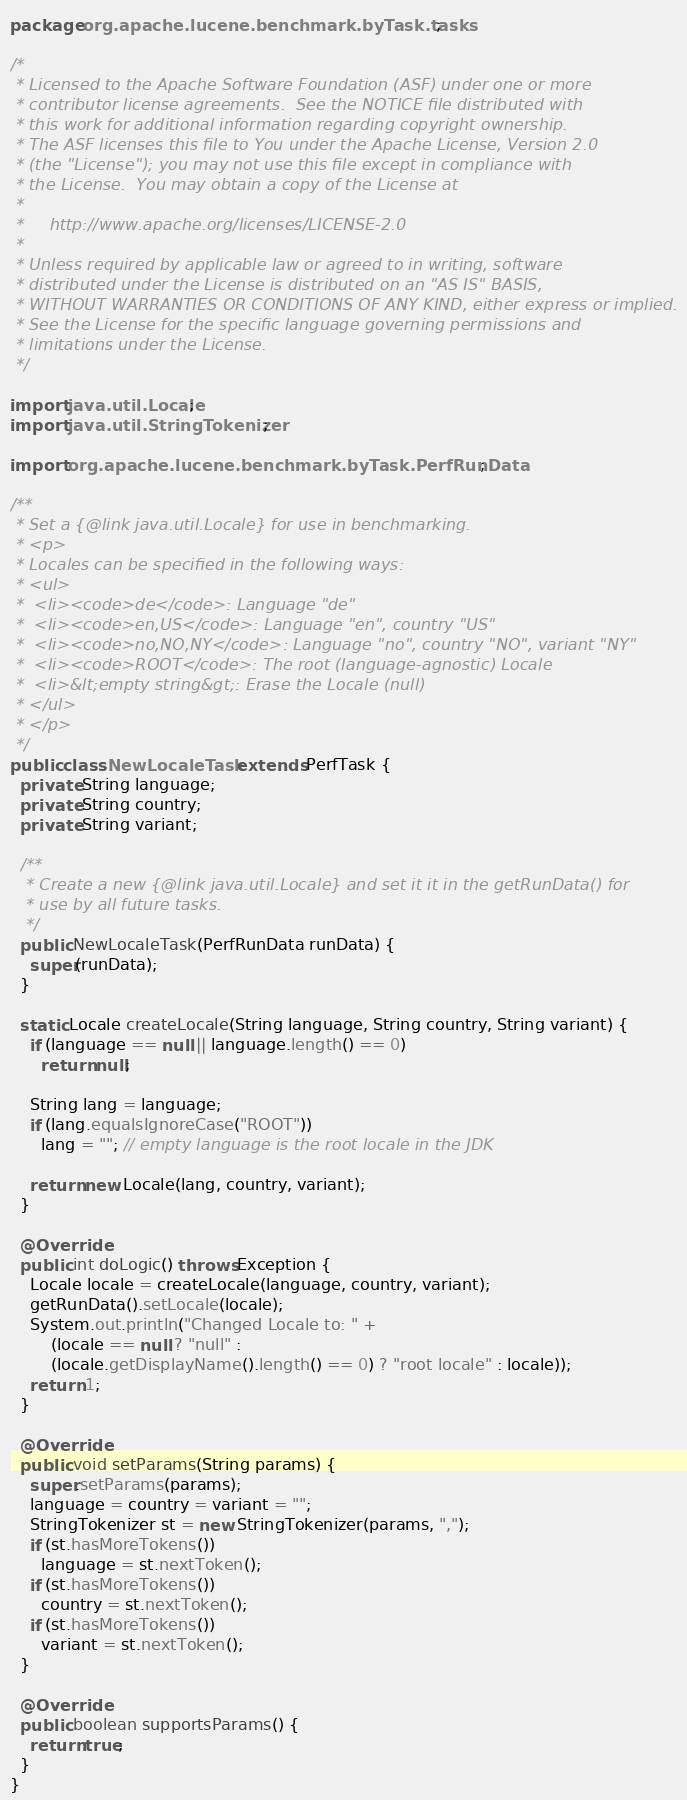Convert code to text. <code><loc_0><loc_0><loc_500><loc_500><_Java_>package org.apache.lucene.benchmark.byTask.tasks;

/*
 * Licensed to the Apache Software Foundation (ASF) under one or more
 * contributor license agreements.  See the NOTICE file distributed with
 * this work for additional information regarding copyright ownership.
 * The ASF licenses this file to You under the Apache License, Version 2.0
 * (the "License"); you may not use this file except in compliance with
 * the License.  You may obtain a copy of the License at
 *
 *     http://www.apache.org/licenses/LICENSE-2.0
 *
 * Unless required by applicable law or agreed to in writing, software
 * distributed under the License is distributed on an "AS IS" BASIS,
 * WITHOUT WARRANTIES OR CONDITIONS OF ANY KIND, either express or implied.
 * See the License for the specific language governing permissions and
 * limitations under the License.
 */

import java.util.Locale;
import java.util.StringTokenizer;

import org.apache.lucene.benchmark.byTask.PerfRunData;

/**
 * Set a {@link java.util.Locale} for use in benchmarking.
 * <p>
 * Locales can be specified in the following ways:
 * <ul>
 *  <li><code>de</code>: Language "de"
 *  <li><code>en,US</code>: Language "en", country "US"
 *  <li><code>no,NO,NY</code>: Language "no", country "NO", variant "NY" 
 *  <li><code>ROOT</code>: The root (language-agnostic) Locale
 *  <li>&lt;empty string&gt;: Erase the Locale (null)
 * </ul>
 * </p>
 */
public class NewLocaleTask extends PerfTask {
  private String language;
  private String country;
  private String variant;
  
  /**
   * Create a new {@link java.util.Locale} and set it it in the getRunData() for
   * use by all future tasks.
   */
  public NewLocaleTask(PerfRunData runData) {
    super(runData);
  }

  static Locale createLocale(String language, String country, String variant) {
    if (language == null || language.length() == 0) 
      return null;
    
    String lang = language;
    if (lang.equalsIgnoreCase("ROOT"))
      lang = ""; // empty language is the root locale in the JDK
      
    return new Locale(lang, country, variant);
  }
  
  @Override
  public int doLogic() throws Exception {
    Locale locale = createLocale(language, country, variant);
    getRunData().setLocale(locale);
    System.out.println("Changed Locale to: " + 
        (locale == null ? "null" : 
        (locale.getDisplayName().length() == 0) ? "root locale" : locale));
    return 1;
  }
  
  @Override
  public void setParams(String params) {
    super.setParams(params);
    language = country = variant = "";
    StringTokenizer st = new StringTokenizer(params, ",");
    if (st.hasMoreTokens())
      language = st.nextToken();
    if (st.hasMoreTokens())
      country = st.nextToken();
    if (st.hasMoreTokens())
      variant = st.nextToken();
  }

  @Override
  public boolean supportsParams() {
    return true;
  }
}
</code> 